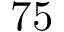<formula> <loc_0><loc_0><loc_500><loc_500>7 5</formula> 